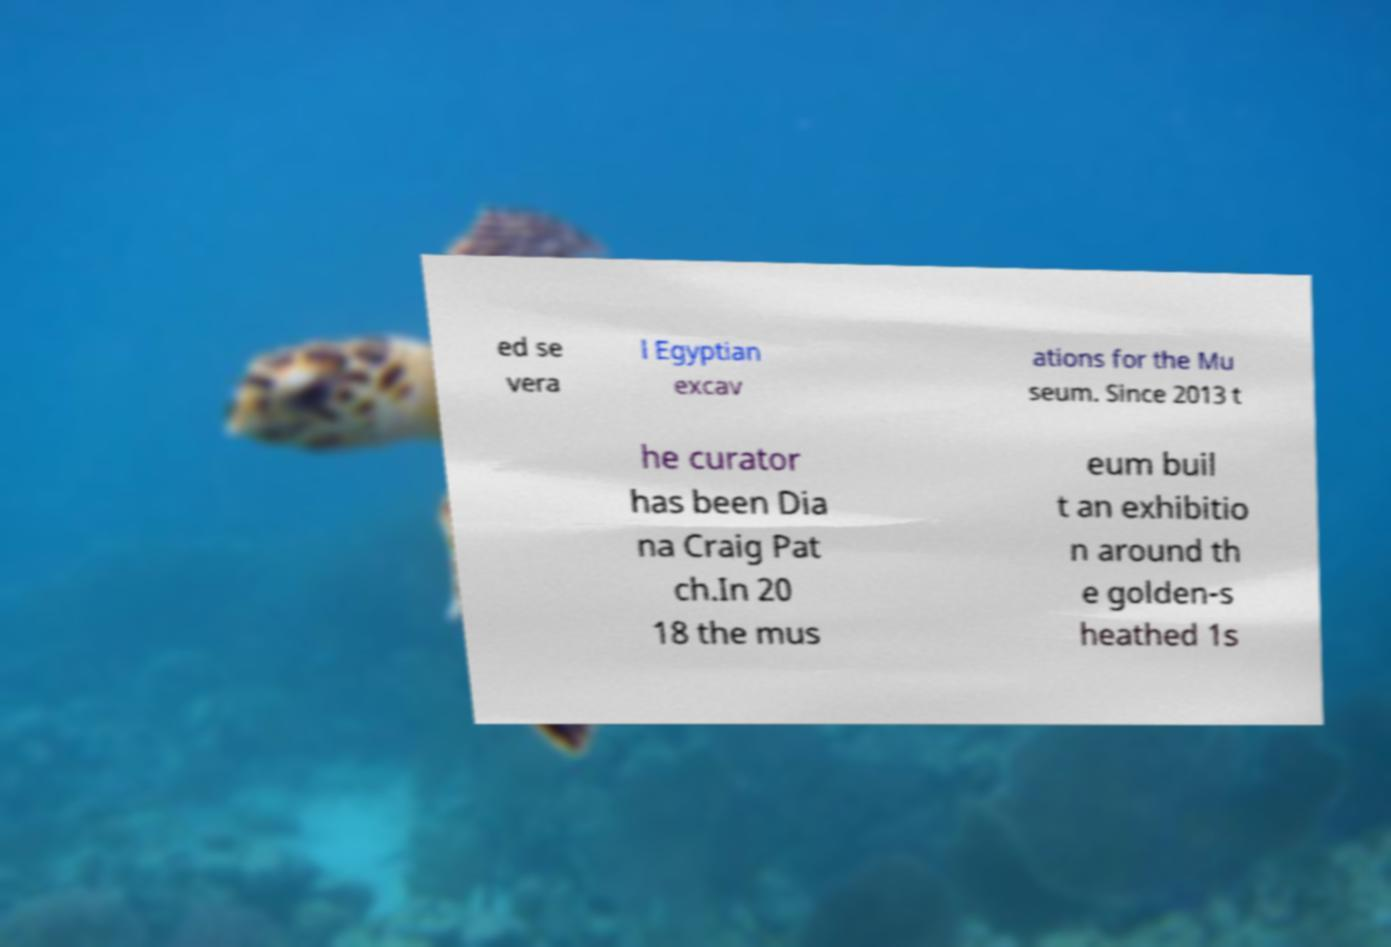For documentation purposes, I need the text within this image transcribed. Could you provide that? ed se vera l Egyptian excav ations for the Mu seum. Since 2013 t he curator has been Dia na Craig Pat ch.In 20 18 the mus eum buil t an exhibitio n around th e golden-s heathed 1s 